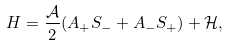Convert formula to latex. <formula><loc_0><loc_0><loc_500><loc_500>H = \frac { \mathcal { A } } { 2 } ( A _ { + } S _ { - } + A _ { - } S _ { + } ) + \mathcal { H } ,</formula> 